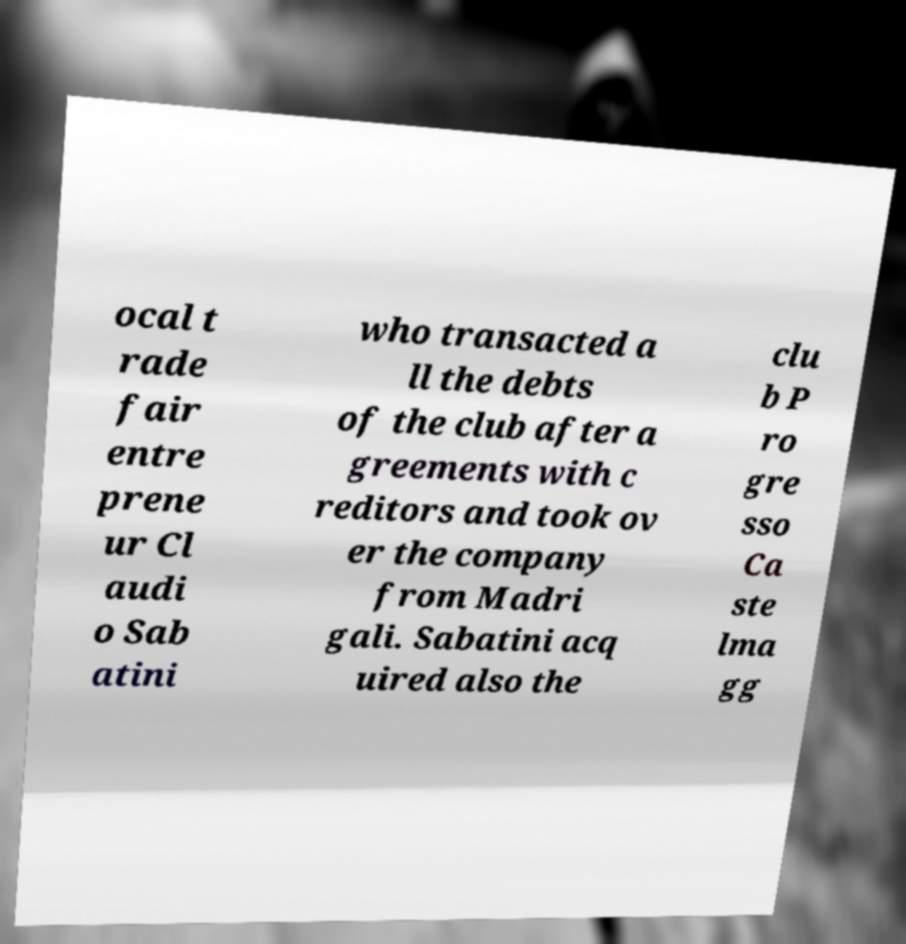Can you accurately transcribe the text from the provided image for me? ocal t rade fair entre prene ur Cl audi o Sab atini who transacted a ll the debts of the club after a greements with c reditors and took ov er the company from Madri gali. Sabatini acq uired also the clu b P ro gre sso Ca ste lma gg 